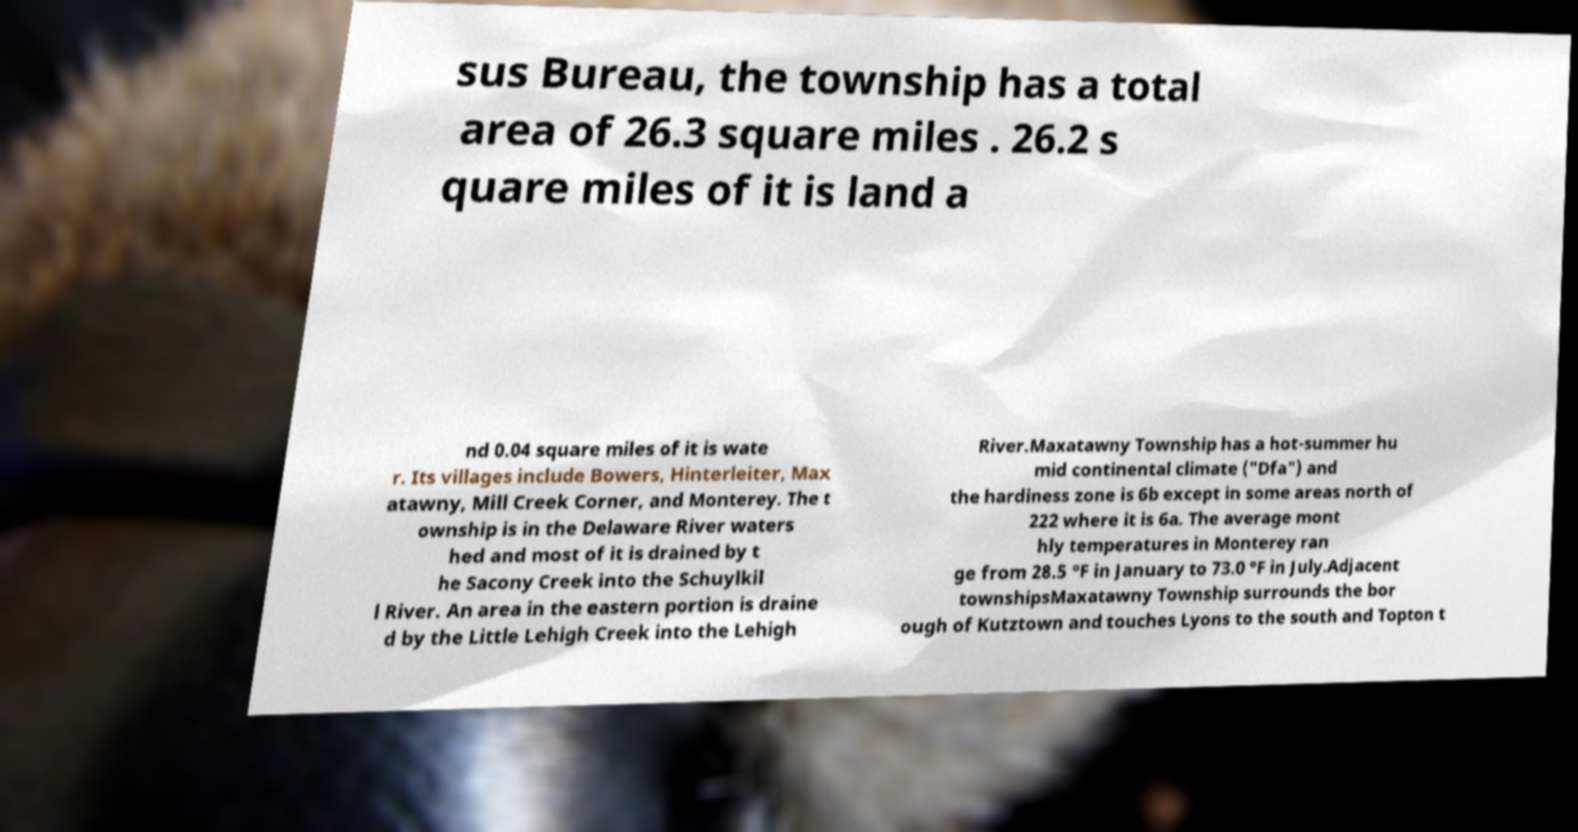What messages or text are displayed in this image? I need them in a readable, typed format. sus Bureau, the township has a total area of 26.3 square miles . 26.2 s quare miles of it is land a nd 0.04 square miles of it is wate r. Its villages include Bowers, Hinterleiter, Max atawny, Mill Creek Corner, and Monterey. The t ownship is in the Delaware River waters hed and most of it is drained by t he Sacony Creek into the Schuylkil l River. An area in the eastern portion is draine d by the Little Lehigh Creek into the Lehigh River.Maxatawny Township has a hot-summer hu mid continental climate ("Dfa") and the hardiness zone is 6b except in some areas north of 222 where it is 6a. The average mont hly temperatures in Monterey ran ge from 28.5 °F in January to 73.0 °F in July.Adjacent townshipsMaxatawny Township surrounds the bor ough of Kutztown and touches Lyons to the south and Topton t 